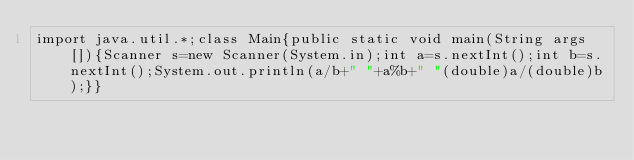Convert code to text. <code><loc_0><loc_0><loc_500><loc_500><_Java_>import java.util.*;class Main{public static void main(String args[]){Scanner s=new Scanner(System.in);int a=s.nextInt();int b=s.nextInt();System.out.println(a/b+" "+a%b+" "(double)a/(double)b);}}</code> 